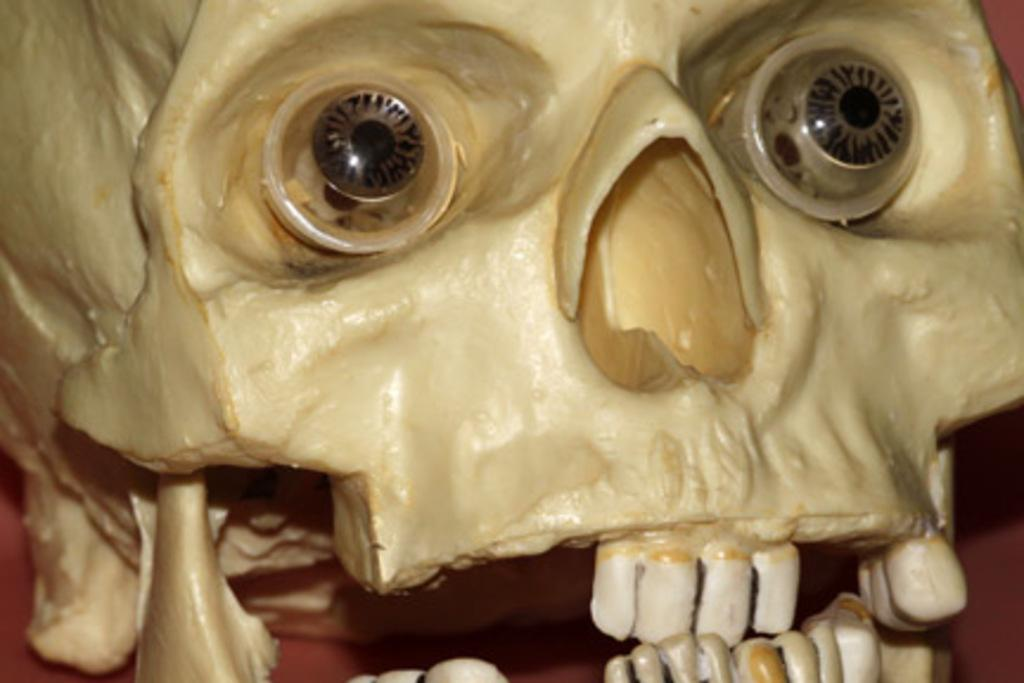What is the main subject of the image? The main subject of the image is a sculpture of a skull. What type of bread can be seen hanging from the twig in the image? There is no bread or twig present in the image; it features a sculpture of a skull. 